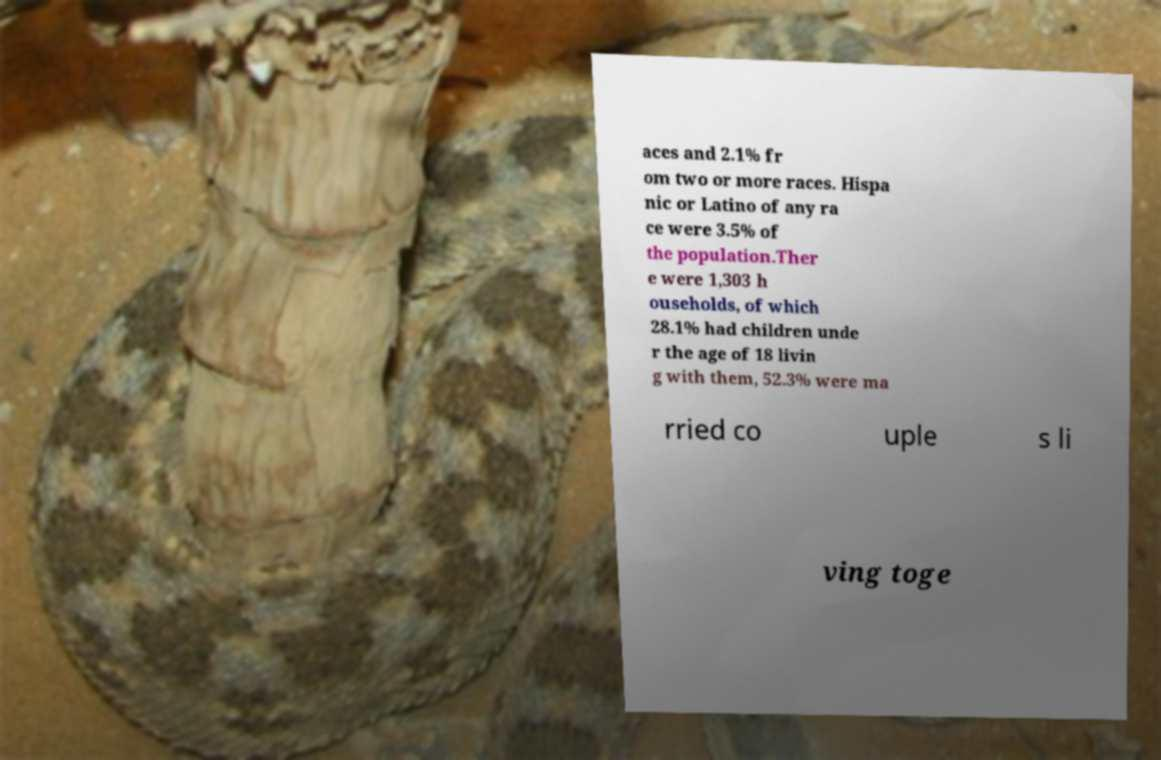There's text embedded in this image that I need extracted. Can you transcribe it verbatim? aces and 2.1% fr om two or more races. Hispa nic or Latino of any ra ce were 3.5% of the population.Ther e were 1,303 h ouseholds, of which 28.1% had children unde r the age of 18 livin g with them, 52.3% were ma rried co uple s li ving toge 